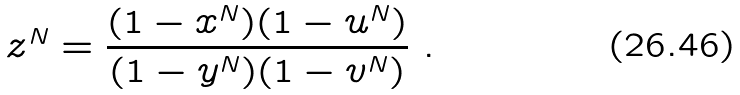<formula> <loc_0><loc_0><loc_500><loc_500>z ^ { N } = \frac { ( 1 - x ^ { N } ) ( 1 - u ^ { N } ) } { ( 1 - y ^ { N } ) ( 1 - v ^ { N } ) } \ .</formula> 